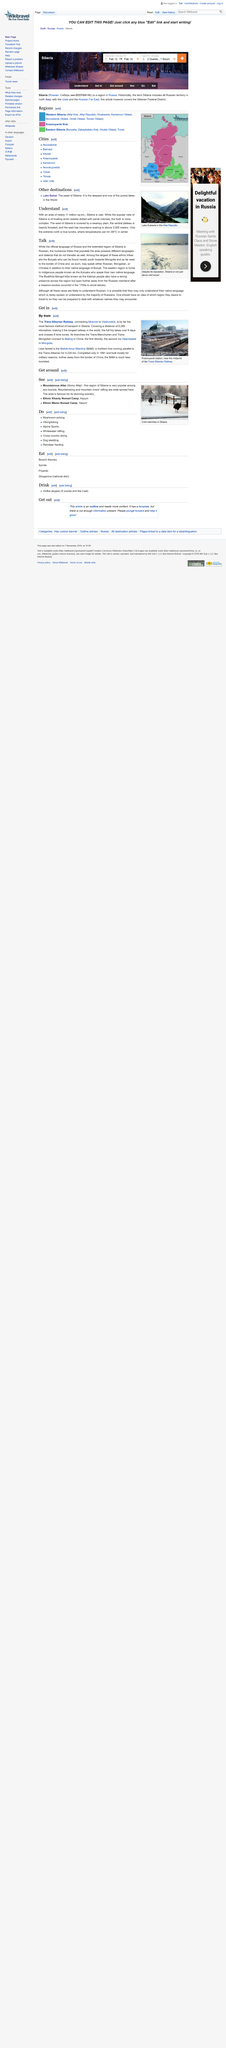Indicate a few pertinent items in this graphic. The main focus of the article is Siberia, a country with an area of nearly 11 million square kilometers. The official language spoken by Siberians is Russian, despite the presence of diverse linguistic groups with unique languages and dialects that may not be mutually comprehensible. The Buryats are one of the largest ethnic tribes in Siberia, and they are known for their unique culture, language, and traditions. 